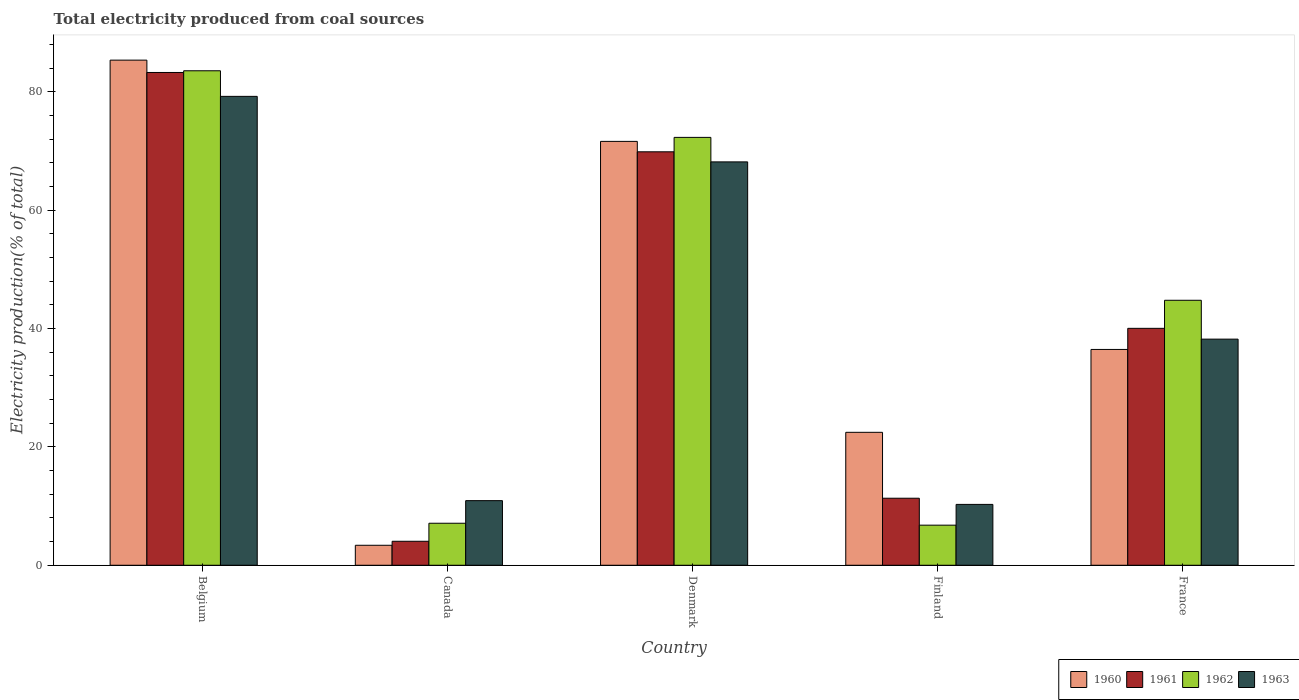How many different coloured bars are there?
Make the answer very short. 4. How many groups of bars are there?
Give a very brief answer. 5. Are the number of bars per tick equal to the number of legend labels?
Make the answer very short. Yes. How many bars are there on the 3rd tick from the right?
Your answer should be very brief. 4. What is the total electricity produced in 1960 in Canada?
Provide a short and direct response. 3.38. Across all countries, what is the maximum total electricity produced in 1960?
Give a very brief answer. 85.36. Across all countries, what is the minimum total electricity produced in 1962?
Keep it short and to the point. 6.78. In which country was the total electricity produced in 1963 minimum?
Keep it short and to the point. Finland. What is the total total electricity produced in 1963 in the graph?
Give a very brief answer. 206.8. What is the difference between the total electricity produced in 1963 in Belgium and that in Denmark?
Make the answer very short. 11.07. What is the difference between the total electricity produced in 1961 in Belgium and the total electricity produced in 1960 in France?
Offer a terse response. 46.8. What is the average total electricity produced in 1960 per country?
Your response must be concise. 43.86. What is the difference between the total electricity produced of/in 1960 and total electricity produced of/in 1961 in Finland?
Your answer should be very brief. 11.14. In how many countries, is the total electricity produced in 1960 greater than 12 %?
Ensure brevity in your answer.  4. What is the ratio of the total electricity produced in 1961 in Canada to that in France?
Keep it short and to the point. 0.1. What is the difference between the highest and the second highest total electricity produced in 1962?
Keep it short and to the point. -11.26. What is the difference between the highest and the lowest total electricity produced in 1960?
Your answer should be very brief. 81.98. In how many countries, is the total electricity produced in 1963 greater than the average total electricity produced in 1963 taken over all countries?
Your answer should be very brief. 2. Is the sum of the total electricity produced in 1963 in Belgium and Denmark greater than the maximum total electricity produced in 1962 across all countries?
Offer a terse response. Yes. Is it the case that in every country, the sum of the total electricity produced in 1961 and total electricity produced in 1960 is greater than the total electricity produced in 1962?
Ensure brevity in your answer.  Yes. How many bars are there?
Provide a succinct answer. 20. Are all the bars in the graph horizontal?
Provide a succinct answer. No. What is the difference between two consecutive major ticks on the Y-axis?
Offer a very short reply. 20. Are the values on the major ticks of Y-axis written in scientific E-notation?
Give a very brief answer. No. Does the graph contain any zero values?
Your response must be concise. No. Where does the legend appear in the graph?
Your answer should be very brief. Bottom right. How many legend labels are there?
Ensure brevity in your answer.  4. What is the title of the graph?
Provide a short and direct response. Total electricity produced from coal sources. Does "1979" appear as one of the legend labels in the graph?
Ensure brevity in your answer.  No. What is the label or title of the Y-axis?
Offer a terse response. Electricity production(% of total). What is the Electricity production(% of total) of 1960 in Belgium?
Keep it short and to the point. 85.36. What is the Electricity production(% of total) in 1961 in Belgium?
Ensure brevity in your answer.  83.27. What is the Electricity production(% of total) of 1962 in Belgium?
Your response must be concise. 83.56. What is the Electricity production(% of total) in 1963 in Belgium?
Your response must be concise. 79.23. What is the Electricity production(% of total) in 1960 in Canada?
Your response must be concise. 3.38. What is the Electricity production(% of total) in 1961 in Canada?
Offer a very short reply. 4.05. What is the Electricity production(% of total) of 1962 in Canada?
Your answer should be compact. 7.1. What is the Electricity production(% of total) of 1963 in Canada?
Your response must be concise. 10.92. What is the Electricity production(% of total) of 1960 in Denmark?
Ensure brevity in your answer.  71.62. What is the Electricity production(% of total) in 1961 in Denmark?
Keep it short and to the point. 69.86. What is the Electricity production(% of total) of 1962 in Denmark?
Your response must be concise. 72.3. What is the Electricity production(% of total) of 1963 in Denmark?
Keep it short and to the point. 68.16. What is the Electricity production(% of total) in 1960 in Finland?
Provide a succinct answer. 22.46. What is the Electricity production(% of total) of 1961 in Finland?
Make the answer very short. 11.33. What is the Electricity production(% of total) in 1962 in Finland?
Offer a terse response. 6.78. What is the Electricity production(% of total) in 1963 in Finland?
Keep it short and to the point. 10.28. What is the Electricity production(% of total) of 1960 in France?
Offer a terse response. 36.47. What is the Electricity production(% of total) of 1961 in France?
Give a very brief answer. 40.03. What is the Electricity production(% of total) of 1962 in France?
Your response must be concise. 44.78. What is the Electricity production(% of total) in 1963 in France?
Ensure brevity in your answer.  38.21. Across all countries, what is the maximum Electricity production(% of total) in 1960?
Your answer should be very brief. 85.36. Across all countries, what is the maximum Electricity production(% of total) in 1961?
Provide a short and direct response. 83.27. Across all countries, what is the maximum Electricity production(% of total) in 1962?
Give a very brief answer. 83.56. Across all countries, what is the maximum Electricity production(% of total) of 1963?
Provide a succinct answer. 79.23. Across all countries, what is the minimum Electricity production(% of total) in 1960?
Your answer should be very brief. 3.38. Across all countries, what is the minimum Electricity production(% of total) of 1961?
Ensure brevity in your answer.  4.05. Across all countries, what is the minimum Electricity production(% of total) of 1962?
Give a very brief answer. 6.78. Across all countries, what is the minimum Electricity production(% of total) in 1963?
Provide a short and direct response. 10.28. What is the total Electricity production(% of total) in 1960 in the graph?
Offer a terse response. 219.29. What is the total Electricity production(% of total) in 1961 in the graph?
Make the answer very short. 208.55. What is the total Electricity production(% of total) of 1962 in the graph?
Keep it short and to the point. 214.51. What is the total Electricity production(% of total) of 1963 in the graph?
Provide a succinct answer. 206.8. What is the difference between the Electricity production(% of total) in 1960 in Belgium and that in Canada?
Offer a terse response. 81.98. What is the difference between the Electricity production(% of total) in 1961 in Belgium and that in Canada?
Your response must be concise. 79.21. What is the difference between the Electricity production(% of total) in 1962 in Belgium and that in Canada?
Provide a short and direct response. 76.46. What is the difference between the Electricity production(% of total) of 1963 in Belgium and that in Canada?
Your response must be concise. 68.31. What is the difference between the Electricity production(% of total) of 1960 in Belgium and that in Denmark?
Offer a terse response. 13.73. What is the difference between the Electricity production(% of total) of 1961 in Belgium and that in Denmark?
Make the answer very short. 13.4. What is the difference between the Electricity production(% of total) of 1962 in Belgium and that in Denmark?
Offer a very short reply. 11.26. What is the difference between the Electricity production(% of total) in 1963 in Belgium and that in Denmark?
Provide a short and direct response. 11.07. What is the difference between the Electricity production(% of total) in 1960 in Belgium and that in Finland?
Ensure brevity in your answer.  62.89. What is the difference between the Electricity production(% of total) of 1961 in Belgium and that in Finland?
Offer a very short reply. 71.94. What is the difference between the Electricity production(% of total) of 1962 in Belgium and that in Finland?
Keep it short and to the point. 76.78. What is the difference between the Electricity production(% of total) of 1963 in Belgium and that in Finland?
Your answer should be very brief. 68.95. What is the difference between the Electricity production(% of total) of 1960 in Belgium and that in France?
Make the answer very short. 48.89. What is the difference between the Electricity production(% of total) of 1961 in Belgium and that in France?
Give a very brief answer. 43.23. What is the difference between the Electricity production(% of total) of 1962 in Belgium and that in France?
Your answer should be compact. 38.78. What is the difference between the Electricity production(% of total) of 1963 in Belgium and that in France?
Your answer should be compact. 41.02. What is the difference between the Electricity production(% of total) of 1960 in Canada and that in Denmark?
Provide a succinct answer. -68.25. What is the difference between the Electricity production(% of total) in 1961 in Canada and that in Denmark?
Your answer should be compact. -65.81. What is the difference between the Electricity production(% of total) of 1962 in Canada and that in Denmark?
Offer a very short reply. -65.2. What is the difference between the Electricity production(% of total) of 1963 in Canada and that in Denmark?
Your answer should be compact. -57.24. What is the difference between the Electricity production(% of total) of 1960 in Canada and that in Finland?
Make the answer very short. -19.09. What is the difference between the Electricity production(% of total) of 1961 in Canada and that in Finland?
Ensure brevity in your answer.  -7.27. What is the difference between the Electricity production(% of total) of 1962 in Canada and that in Finland?
Your answer should be compact. 0.32. What is the difference between the Electricity production(% of total) in 1963 in Canada and that in Finland?
Offer a very short reply. 0.63. What is the difference between the Electricity production(% of total) in 1960 in Canada and that in France?
Give a very brief answer. -33.09. What is the difference between the Electricity production(% of total) in 1961 in Canada and that in France?
Provide a succinct answer. -35.98. What is the difference between the Electricity production(% of total) of 1962 in Canada and that in France?
Offer a terse response. -37.68. What is the difference between the Electricity production(% of total) of 1963 in Canada and that in France?
Ensure brevity in your answer.  -27.29. What is the difference between the Electricity production(% of total) in 1960 in Denmark and that in Finland?
Provide a short and direct response. 49.16. What is the difference between the Electricity production(% of total) of 1961 in Denmark and that in Finland?
Ensure brevity in your answer.  58.54. What is the difference between the Electricity production(% of total) in 1962 in Denmark and that in Finland?
Your response must be concise. 65.53. What is the difference between the Electricity production(% of total) in 1963 in Denmark and that in Finland?
Provide a short and direct response. 57.88. What is the difference between the Electricity production(% of total) in 1960 in Denmark and that in France?
Provide a succinct answer. 35.16. What is the difference between the Electricity production(% of total) of 1961 in Denmark and that in France?
Ensure brevity in your answer.  29.83. What is the difference between the Electricity production(% of total) of 1962 in Denmark and that in France?
Your answer should be very brief. 27.52. What is the difference between the Electricity production(% of total) in 1963 in Denmark and that in France?
Your answer should be very brief. 29.95. What is the difference between the Electricity production(% of total) in 1960 in Finland and that in France?
Offer a terse response. -14.01. What is the difference between the Electricity production(% of total) of 1961 in Finland and that in France?
Provide a short and direct response. -28.71. What is the difference between the Electricity production(% of total) of 1962 in Finland and that in France?
Offer a terse response. -38. What is the difference between the Electricity production(% of total) in 1963 in Finland and that in France?
Your answer should be very brief. -27.93. What is the difference between the Electricity production(% of total) of 1960 in Belgium and the Electricity production(% of total) of 1961 in Canada?
Give a very brief answer. 81.3. What is the difference between the Electricity production(% of total) of 1960 in Belgium and the Electricity production(% of total) of 1962 in Canada?
Provide a short and direct response. 78.26. What is the difference between the Electricity production(% of total) of 1960 in Belgium and the Electricity production(% of total) of 1963 in Canada?
Your response must be concise. 74.44. What is the difference between the Electricity production(% of total) in 1961 in Belgium and the Electricity production(% of total) in 1962 in Canada?
Provide a short and direct response. 76.17. What is the difference between the Electricity production(% of total) of 1961 in Belgium and the Electricity production(% of total) of 1963 in Canada?
Ensure brevity in your answer.  72.35. What is the difference between the Electricity production(% of total) in 1962 in Belgium and the Electricity production(% of total) in 1963 in Canada?
Make the answer very short. 72.64. What is the difference between the Electricity production(% of total) of 1960 in Belgium and the Electricity production(% of total) of 1961 in Denmark?
Your answer should be very brief. 15.49. What is the difference between the Electricity production(% of total) in 1960 in Belgium and the Electricity production(% of total) in 1962 in Denmark?
Make the answer very short. 13.05. What is the difference between the Electricity production(% of total) of 1960 in Belgium and the Electricity production(% of total) of 1963 in Denmark?
Your answer should be compact. 17.19. What is the difference between the Electricity production(% of total) of 1961 in Belgium and the Electricity production(% of total) of 1962 in Denmark?
Provide a short and direct response. 10.97. What is the difference between the Electricity production(% of total) in 1961 in Belgium and the Electricity production(% of total) in 1963 in Denmark?
Make the answer very short. 15.11. What is the difference between the Electricity production(% of total) in 1962 in Belgium and the Electricity production(% of total) in 1963 in Denmark?
Ensure brevity in your answer.  15.4. What is the difference between the Electricity production(% of total) of 1960 in Belgium and the Electricity production(% of total) of 1961 in Finland?
Give a very brief answer. 74.03. What is the difference between the Electricity production(% of total) of 1960 in Belgium and the Electricity production(% of total) of 1962 in Finland?
Provide a short and direct response. 78.58. What is the difference between the Electricity production(% of total) of 1960 in Belgium and the Electricity production(% of total) of 1963 in Finland?
Keep it short and to the point. 75.07. What is the difference between the Electricity production(% of total) of 1961 in Belgium and the Electricity production(% of total) of 1962 in Finland?
Offer a terse response. 76.49. What is the difference between the Electricity production(% of total) of 1961 in Belgium and the Electricity production(% of total) of 1963 in Finland?
Offer a terse response. 72.98. What is the difference between the Electricity production(% of total) in 1962 in Belgium and the Electricity production(% of total) in 1963 in Finland?
Your answer should be very brief. 73.27. What is the difference between the Electricity production(% of total) in 1960 in Belgium and the Electricity production(% of total) in 1961 in France?
Your answer should be very brief. 45.32. What is the difference between the Electricity production(% of total) of 1960 in Belgium and the Electricity production(% of total) of 1962 in France?
Ensure brevity in your answer.  40.58. What is the difference between the Electricity production(% of total) of 1960 in Belgium and the Electricity production(% of total) of 1963 in France?
Offer a very short reply. 47.14. What is the difference between the Electricity production(% of total) in 1961 in Belgium and the Electricity production(% of total) in 1962 in France?
Offer a terse response. 38.49. What is the difference between the Electricity production(% of total) of 1961 in Belgium and the Electricity production(% of total) of 1963 in France?
Offer a very short reply. 45.06. What is the difference between the Electricity production(% of total) in 1962 in Belgium and the Electricity production(% of total) in 1963 in France?
Make the answer very short. 45.35. What is the difference between the Electricity production(% of total) of 1960 in Canada and the Electricity production(% of total) of 1961 in Denmark?
Your answer should be compact. -66.49. What is the difference between the Electricity production(% of total) of 1960 in Canada and the Electricity production(% of total) of 1962 in Denmark?
Make the answer very short. -68.92. What is the difference between the Electricity production(% of total) of 1960 in Canada and the Electricity production(% of total) of 1963 in Denmark?
Offer a very short reply. -64.78. What is the difference between the Electricity production(% of total) of 1961 in Canada and the Electricity production(% of total) of 1962 in Denmark?
Your answer should be very brief. -68.25. What is the difference between the Electricity production(% of total) in 1961 in Canada and the Electricity production(% of total) in 1963 in Denmark?
Offer a terse response. -64.11. What is the difference between the Electricity production(% of total) in 1962 in Canada and the Electricity production(% of total) in 1963 in Denmark?
Offer a very short reply. -61.06. What is the difference between the Electricity production(% of total) in 1960 in Canada and the Electricity production(% of total) in 1961 in Finland?
Give a very brief answer. -7.95. What is the difference between the Electricity production(% of total) of 1960 in Canada and the Electricity production(% of total) of 1962 in Finland?
Offer a very short reply. -3.4. What is the difference between the Electricity production(% of total) in 1960 in Canada and the Electricity production(% of total) in 1963 in Finland?
Your answer should be very brief. -6.91. What is the difference between the Electricity production(% of total) of 1961 in Canada and the Electricity production(% of total) of 1962 in Finland?
Keep it short and to the point. -2.72. What is the difference between the Electricity production(% of total) in 1961 in Canada and the Electricity production(% of total) in 1963 in Finland?
Give a very brief answer. -6.23. What is the difference between the Electricity production(% of total) of 1962 in Canada and the Electricity production(% of total) of 1963 in Finland?
Make the answer very short. -3.18. What is the difference between the Electricity production(% of total) in 1960 in Canada and the Electricity production(% of total) in 1961 in France?
Ensure brevity in your answer.  -36.66. What is the difference between the Electricity production(% of total) in 1960 in Canada and the Electricity production(% of total) in 1962 in France?
Offer a terse response. -41.4. What is the difference between the Electricity production(% of total) in 1960 in Canada and the Electricity production(% of total) in 1963 in France?
Give a very brief answer. -34.83. What is the difference between the Electricity production(% of total) in 1961 in Canada and the Electricity production(% of total) in 1962 in France?
Your response must be concise. -40.72. What is the difference between the Electricity production(% of total) in 1961 in Canada and the Electricity production(% of total) in 1963 in France?
Your response must be concise. -34.16. What is the difference between the Electricity production(% of total) in 1962 in Canada and the Electricity production(% of total) in 1963 in France?
Your answer should be compact. -31.11. What is the difference between the Electricity production(% of total) in 1960 in Denmark and the Electricity production(% of total) in 1961 in Finland?
Your answer should be compact. 60.3. What is the difference between the Electricity production(% of total) of 1960 in Denmark and the Electricity production(% of total) of 1962 in Finland?
Keep it short and to the point. 64.85. What is the difference between the Electricity production(% of total) in 1960 in Denmark and the Electricity production(% of total) in 1963 in Finland?
Your answer should be very brief. 61.34. What is the difference between the Electricity production(% of total) in 1961 in Denmark and the Electricity production(% of total) in 1962 in Finland?
Provide a short and direct response. 63.09. What is the difference between the Electricity production(% of total) of 1961 in Denmark and the Electricity production(% of total) of 1963 in Finland?
Offer a terse response. 59.58. What is the difference between the Electricity production(% of total) in 1962 in Denmark and the Electricity production(% of total) in 1963 in Finland?
Keep it short and to the point. 62.02. What is the difference between the Electricity production(% of total) of 1960 in Denmark and the Electricity production(% of total) of 1961 in France?
Give a very brief answer. 31.59. What is the difference between the Electricity production(% of total) in 1960 in Denmark and the Electricity production(% of total) in 1962 in France?
Ensure brevity in your answer.  26.85. What is the difference between the Electricity production(% of total) of 1960 in Denmark and the Electricity production(% of total) of 1963 in France?
Your answer should be compact. 33.41. What is the difference between the Electricity production(% of total) of 1961 in Denmark and the Electricity production(% of total) of 1962 in France?
Make the answer very short. 25.09. What is the difference between the Electricity production(% of total) in 1961 in Denmark and the Electricity production(% of total) in 1963 in France?
Offer a very short reply. 31.65. What is the difference between the Electricity production(% of total) of 1962 in Denmark and the Electricity production(% of total) of 1963 in France?
Make the answer very short. 34.09. What is the difference between the Electricity production(% of total) of 1960 in Finland and the Electricity production(% of total) of 1961 in France?
Ensure brevity in your answer.  -17.57. What is the difference between the Electricity production(% of total) in 1960 in Finland and the Electricity production(% of total) in 1962 in France?
Make the answer very short. -22.31. What is the difference between the Electricity production(% of total) in 1960 in Finland and the Electricity production(% of total) in 1963 in France?
Your answer should be very brief. -15.75. What is the difference between the Electricity production(% of total) of 1961 in Finland and the Electricity production(% of total) of 1962 in France?
Offer a terse response. -33.45. What is the difference between the Electricity production(% of total) in 1961 in Finland and the Electricity production(% of total) in 1963 in France?
Offer a very short reply. -26.88. What is the difference between the Electricity production(% of total) in 1962 in Finland and the Electricity production(% of total) in 1963 in France?
Your response must be concise. -31.44. What is the average Electricity production(% of total) in 1960 per country?
Offer a very short reply. 43.86. What is the average Electricity production(% of total) of 1961 per country?
Offer a very short reply. 41.71. What is the average Electricity production(% of total) of 1962 per country?
Provide a short and direct response. 42.9. What is the average Electricity production(% of total) in 1963 per country?
Make the answer very short. 41.36. What is the difference between the Electricity production(% of total) of 1960 and Electricity production(% of total) of 1961 in Belgium?
Offer a terse response. 2.09. What is the difference between the Electricity production(% of total) in 1960 and Electricity production(% of total) in 1962 in Belgium?
Provide a succinct answer. 1.8. What is the difference between the Electricity production(% of total) in 1960 and Electricity production(% of total) in 1963 in Belgium?
Your answer should be compact. 6.12. What is the difference between the Electricity production(% of total) in 1961 and Electricity production(% of total) in 1962 in Belgium?
Keep it short and to the point. -0.29. What is the difference between the Electricity production(% of total) of 1961 and Electricity production(% of total) of 1963 in Belgium?
Provide a succinct answer. 4.04. What is the difference between the Electricity production(% of total) of 1962 and Electricity production(% of total) of 1963 in Belgium?
Give a very brief answer. 4.33. What is the difference between the Electricity production(% of total) in 1960 and Electricity production(% of total) in 1961 in Canada?
Provide a short and direct response. -0.68. What is the difference between the Electricity production(% of total) of 1960 and Electricity production(% of total) of 1962 in Canada?
Keep it short and to the point. -3.72. What is the difference between the Electricity production(% of total) of 1960 and Electricity production(% of total) of 1963 in Canada?
Your response must be concise. -7.54. What is the difference between the Electricity production(% of total) in 1961 and Electricity production(% of total) in 1962 in Canada?
Offer a terse response. -3.04. What is the difference between the Electricity production(% of total) in 1961 and Electricity production(% of total) in 1963 in Canada?
Your response must be concise. -6.86. What is the difference between the Electricity production(% of total) of 1962 and Electricity production(% of total) of 1963 in Canada?
Ensure brevity in your answer.  -3.82. What is the difference between the Electricity production(% of total) of 1960 and Electricity production(% of total) of 1961 in Denmark?
Provide a short and direct response. 1.76. What is the difference between the Electricity production(% of total) in 1960 and Electricity production(% of total) in 1962 in Denmark?
Provide a short and direct response. -0.68. What is the difference between the Electricity production(% of total) of 1960 and Electricity production(% of total) of 1963 in Denmark?
Offer a terse response. 3.46. What is the difference between the Electricity production(% of total) of 1961 and Electricity production(% of total) of 1962 in Denmark?
Provide a succinct answer. -2.44. What is the difference between the Electricity production(% of total) of 1961 and Electricity production(% of total) of 1963 in Denmark?
Give a very brief answer. 1.7. What is the difference between the Electricity production(% of total) of 1962 and Electricity production(% of total) of 1963 in Denmark?
Ensure brevity in your answer.  4.14. What is the difference between the Electricity production(% of total) of 1960 and Electricity production(% of total) of 1961 in Finland?
Your answer should be very brief. 11.14. What is the difference between the Electricity production(% of total) in 1960 and Electricity production(% of total) in 1962 in Finland?
Provide a short and direct response. 15.69. What is the difference between the Electricity production(% of total) in 1960 and Electricity production(% of total) in 1963 in Finland?
Make the answer very short. 12.18. What is the difference between the Electricity production(% of total) in 1961 and Electricity production(% of total) in 1962 in Finland?
Ensure brevity in your answer.  4.55. What is the difference between the Electricity production(% of total) of 1961 and Electricity production(% of total) of 1963 in Finland?
Your answer should be very brief. 1.04. What is the difference between the Electricity production(% of total) in 1962 and Electricity production(% of total) in 1963 in Finland?
Give a very brief answer. -3.51. What is the difference between the Electricity production(% of total) of 1960 and Electricity production(% of total) of 1961 in France?
Your answer should be compact. -3.57. What is the difference between the Electricity production(% of total) in 1960 and Electricity production(% of total) in 1962 in France?
Your answer should be very brief. -8.31. What is the difference between the Electricity production(% of total) in 1960 and Electricity production(% of total) in 1963 in France?
Your answer should be very brief. -1.74. What is the difference between the Electricity production(% of total) in 1961 and Electricity production(% of total) in 1962 in France?
Make the answer very short. -4.74. What is the difference between the Electricity production(% of total) in 1961 and Electricity production(% of total) in 1963 in France?
Your answer should be compact. 1.82. What is the difference between the Electricity production(% of total) of 1962 and Electricity production(% of total) of 1963 in France?
Make the answer very short. 6.57. What is the ratio of the Electricity production(% of total) of 1960 in Belgium to that in Canada?
Your answer should be compact. 25.27. What is the ratio of the Electricity production(% of total) in 1961 in Belgium to that in Canada?
Your response must be concise. 20.54. What is the ratio of the Electricity production(% of total) of 1962 in Belgium to that in Canada?
Give a very brief answer. 11.77. What is the ratio of the Electricity production(% of total) in 1963 in Belgium to that in Canada?
Your answer should be compact. 7.26. What is the ratio of the Electricity production(% of total) in 1960 in Belgium to that in Denmark?
Provide a succinct answer. 1.19. What is the ratio of the Electricity production(% of total) of 1961 in Belgium to that in Denmark?
Offer a terse response. 1.19. What is the ratio of the Electricity production(% of total) in 1962 in Belgium to that in Denmark?
Provide a succinct answer. 1.16. What is the ratio of the Electricity production(% of total) of 1963 in Belgium to that in Denmark?
Offer a very short reply. 1.16. What is the ratio of the Electricity production(% of total) of 1960 in Belgium to that in Finland?
Make the answer very short. 3.8. What is the ratio of the Electricity production(% of total) of 1961 in Belgium to that in Finland?
Your response must be concise. 7.35. What is the ratio of the Electricity production(% of total) in 1962 in Belgium to that in Finland?
Provide a short and direct response. 12.33. What is the ratio of the Electricity production(% of total) of 1963 in Belgium to that in Finland?
Ensure brevity in your answer.  7.7. What is the ratio of the Electricity production(% of total) of 1960 in Belgium to that in France?
Give a very brief answer. 2.34. What is the ratio of the Electricity production(% of total) of 1961 in Belgium to that in France?
Your answer should be very brief. 2.08. What is the ratio of the Electricity production(% of total) of 1962 in Belgium to that in France?
Keep it short and to the point. 1.87. What is the ratio of the Electricity production(% of total) of 1963 in Belgium to that in France?
Provide a succinct answer. 2.07. What is the ratio of the Electricity production(% of total) in 1960 in Canada to that in Denmark?
Your answer should be very brief. 0.05. What is the ratio of the Electricity production(% of total) in 1961 in Canada to that in Denmark?
Ensure brevity in your answer.  0.06. What is the ratio of the Electricity production(% of total) of 1962 in Canada to that in Denmark?
Make the answer very short. 0.1. What is the ratio of the Electricity production(% of total) of 1963 in Canada to that in Denmark?
Give a very brief answer. 0.16. What is the ratio of the Electricity production(% of total) in 1960 in Canada to that in Finland?
Ensure brevity in your answer.  0.15. What is the ratio of the Electricity production(% of total) of 1961 in Canada to that in Finland?
Provide a succinct answer. 0.36. What is the ratio of the Electricity production(% of total) of 1962 in Canada to that in Finland?
Offer a terse response. 1.05. What is the ratio of the Electricity production(% of total) of 1963 in Canada to that in Finland?
Offer a terse response. 1.06. What is the ratio of the Electricity production(% of total) of 1960 in Canada to that in France?
Give a very brief answer. 0.09. What is the ratio of the Electricity production(% of total) in 1961 in Canada to that in France?
Give a very brief answer. 0.1. What is the ratio of the Electricity production(% of total) of 1962 in Canada to that in France?
Give a very brief answer. 0.16. What is the ratio of the Electricity production(% of total) in 1963 in Canada to that in France?
Your response must be concise. 0.29. What is the ratio of the Electricity production(% of total) of 1960 in Denmark to that in Finland?
Give a very brief answer. 3.19. What is the ratio of the Electricity production(% of total) of 1961 in Denmark to that in Finland?
Give a very brief answer. 6.17. What is the ratio of the Electricity production(% of total) of 1962 in Denmark to that in Finland?
Keep it short and to the point. 10.67. What is the ratio of the Electricity production(% of total) of 1963 in Denmark to that in Finland?
Provide a short and direct response. 6.63. What is the ratio of the Electricity production(% of total) of 1960 in Denmark to that in France?
Ensure brevity in your answer.  1.96. What is the ratio of the Electricity production(% of total) in 1961 in Denmark to that in France?
Make the answer very short. 1.75. What is the ratio of the Electricity production(% of total) of 1962 in Denmark to that in France?
Provide a succinct answer. 1.61. What is the ratio of the Electricity production(% of total) of 1963 in Denmark to that in France?
Provide a short and direct response. 1.78. What is the ratio of the Electricity production(% of total) of 1960 in Finland to that in France?
Offer a terse response. 0.62. What is the ratio of the Electricity production(% of total) in 1961 in Finland to that in France?
Your answer should be very brief. 0.28. What is the ratio of the Electricity production(% of total) in 1962 in Finland to that in France?
Offer a very short reply. 0.15. What is the ratio of the Electricity production(% of total) in 1963 in Finland to that in France?
Keep it short and to the point. 0.27. What is the difference between the highest and the second highest Electricity production(% of total) in 1960?
Your response must be concise. 13.73. What is the difference between the highest and the second highest Electricity production(% of total) in 1961?
Your answer should be very brief. 13.4. What is the difference between the highest and the second highest Electricity production(% of total) of 1962?
Make the answer very short. 11.26. What is the difference between the highest and the second highest Electricity production(% of total) of 1963?
Offer a terse response. 11.07. What is the difference between the highest and the lowest Electricity production(% of total) in 1960?
Ensure brevity in your answer.  81.98. What is the difference between the highest and the lowest Electricity production(% of total) of 1961?
Keep it short and to the point. 79.21. What is the difference between the highest and the lowest Electricity production(% of total) in 1962?
Your answer should be very brief. 76.78. What is the difference between the highest and the lowest Electricity production(% of total) in 1963?
Give a very brief answer. 68.95. 